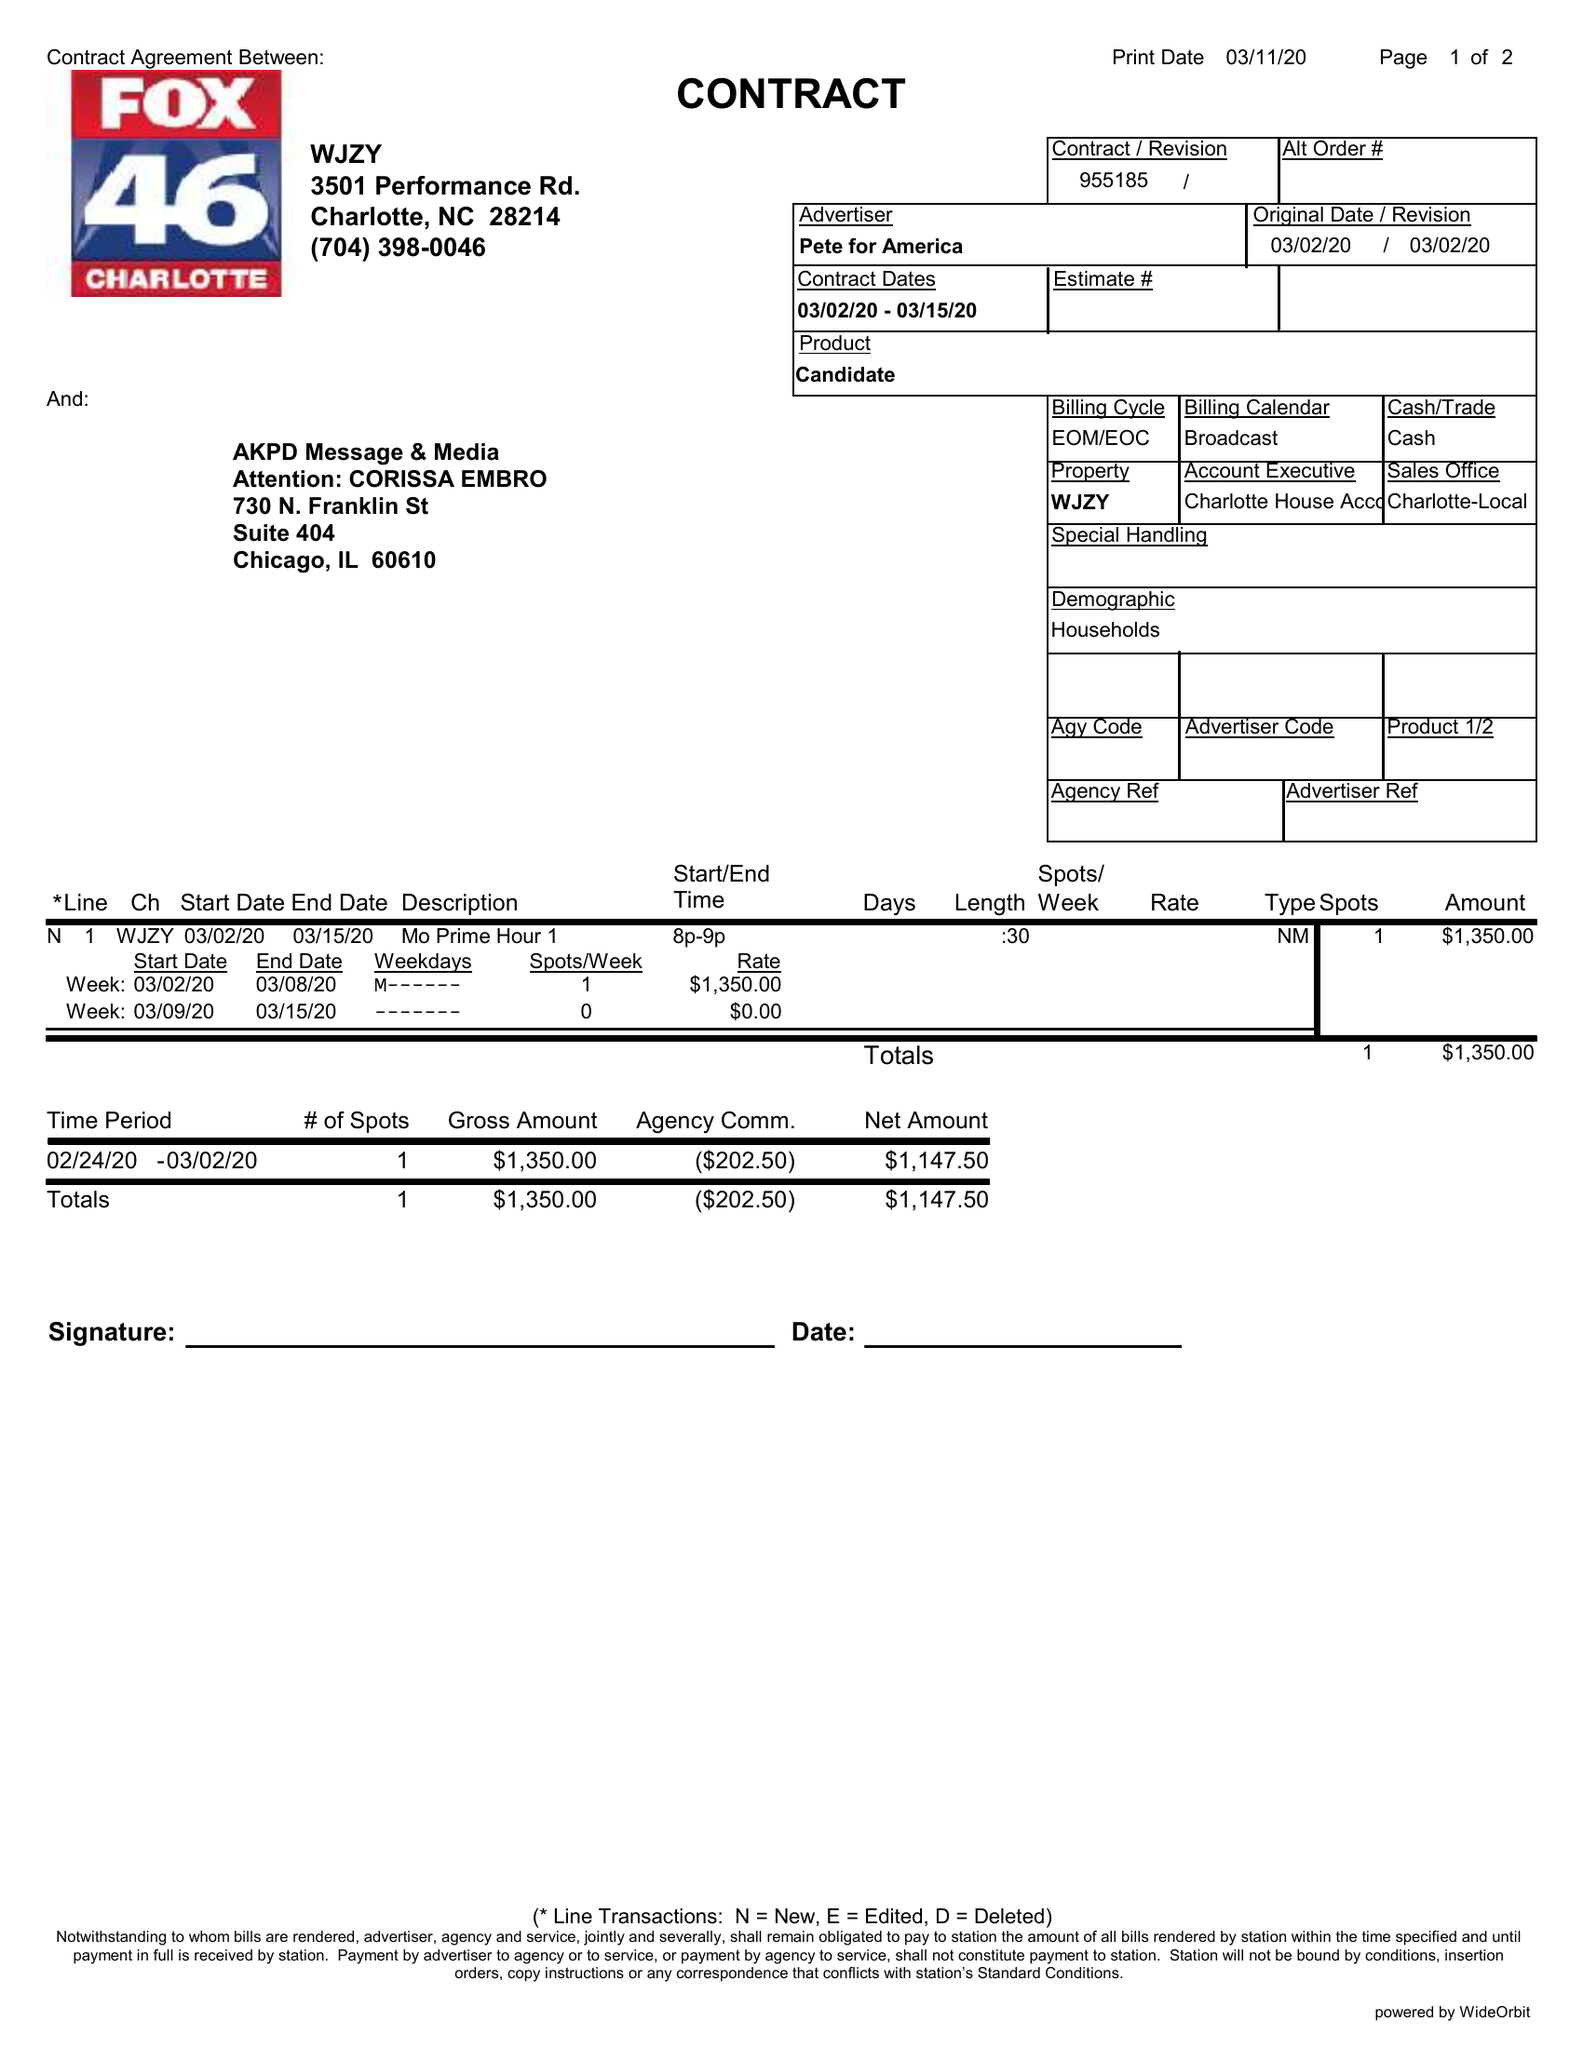What is the value for the flight_from?
Answer the question using a single word or phrase. 03/02/20 